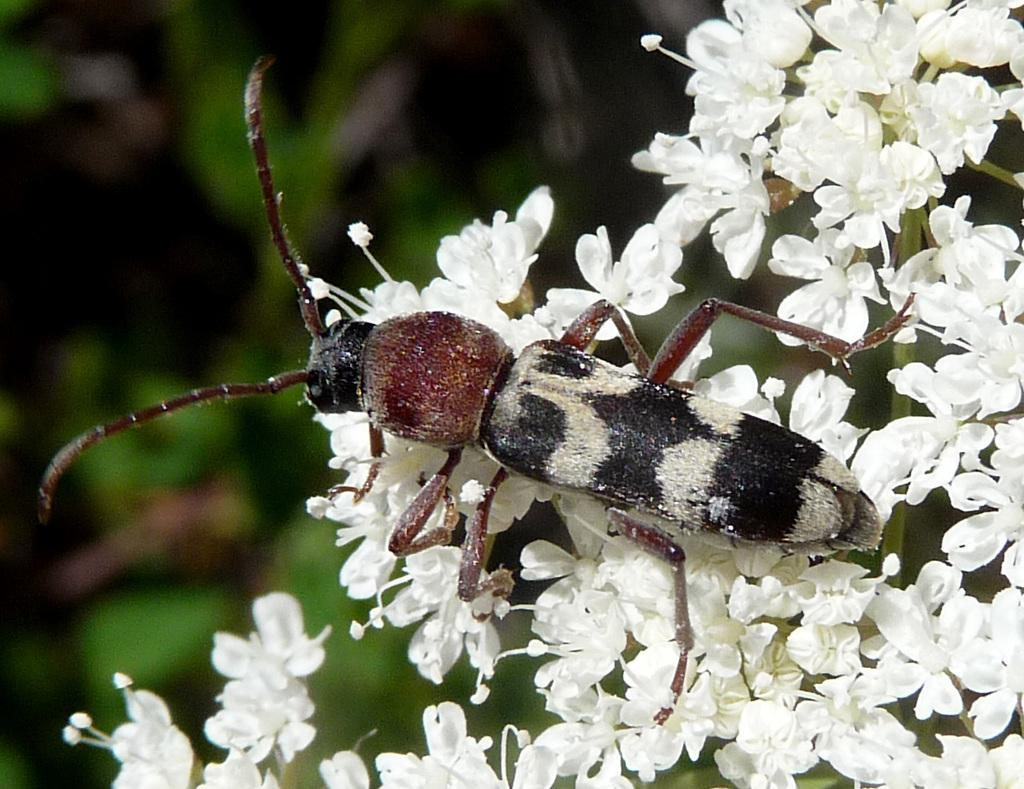What type of creature can be seen in the image? There is an insect in the image. Where is the insect located? The insect is on a flower. Can you tell me what type of vest the grandmother is wearing at the zoo in the image? There is no grandmother, vest, or zoo present in the image; it only features an insect on a flower. 